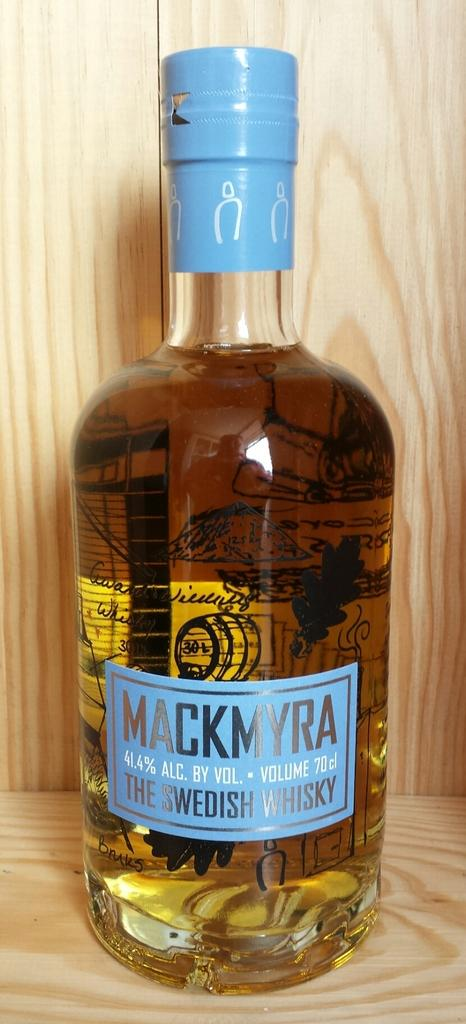Provide a one-sentence caption for the provided image. A bottle of Mackmyra Swedish whiskey with a blue wrap on top. 